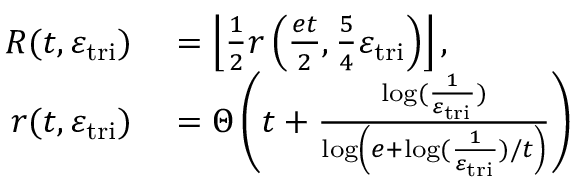<formula> <loc_0><loc_0><loc_500><loc_500>\begin{array} { r l } { R ( t , \varepsilon _ { t r i } ) } & = \left \lfloor \frac { 1 } { 2 } r \left ( \frac { e t } { 2 } , \frac { 5 } { 4 } \varepsilon _ { t r i } \right ) \right \rfloor , } \\ { r ( t , \varepsilon _ { t r i } ) } & = \Theta \left ( t + \frac { \log ( \frac { 1 } { \varepsilon _ { t r i } } ) } { \log \left ( e + \log ( \frac { 1 } { \varepsilon _ { t r i } } ) / t \right ) } \right ) } \end{array}</formula> 